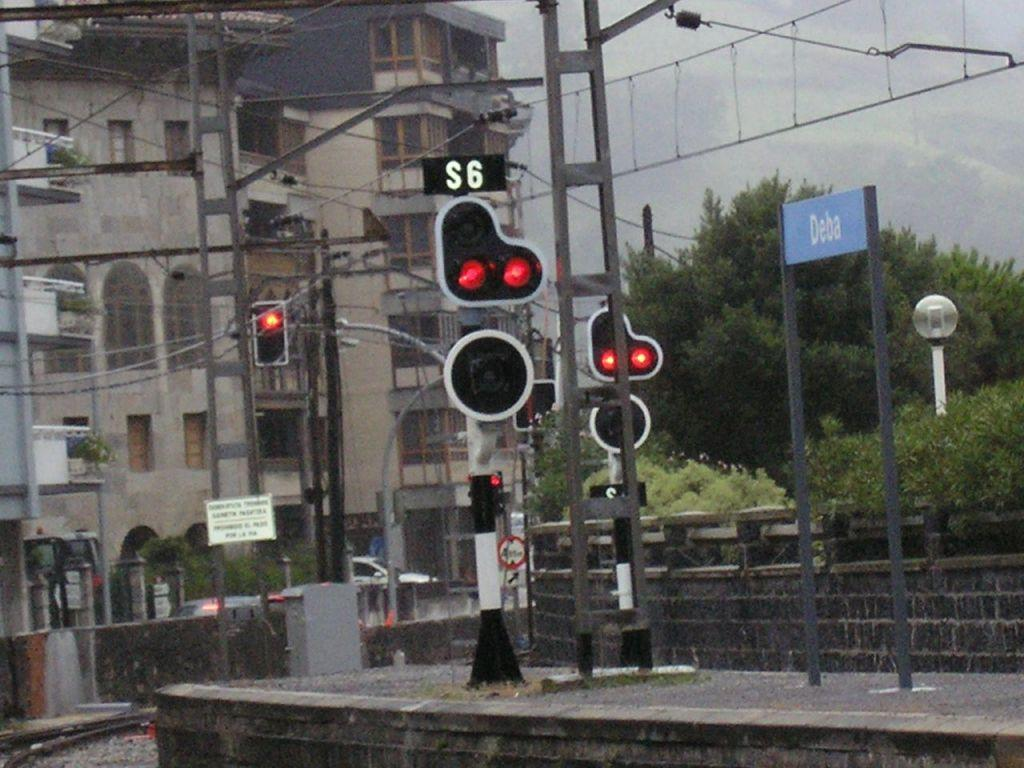<image>
Relay a brief, clear account of the picture shown. Dual red traffic light labeled S6 is on the top of a platform in front of the large building. 